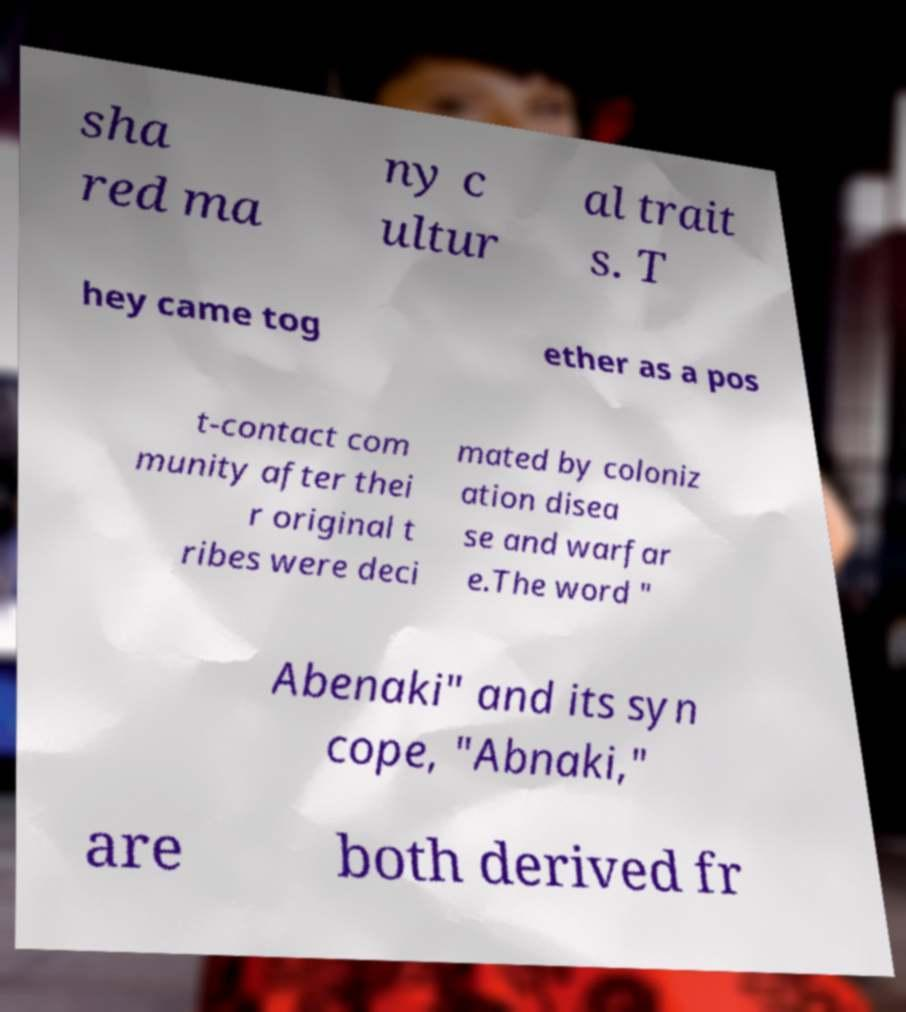Can you read and provide the text displayed in the image?This photo seems to have some interesting text. Can you extract and type it out for me? sha red ma ny c ultur al trait s. T hey came tog ether as a pos t-contact com munity after thei r original t ribes were deci mated by coloniz ation disea se and warfar e.The word " Abenaki" and its syn cope, "Abnaki," are both derived fr 